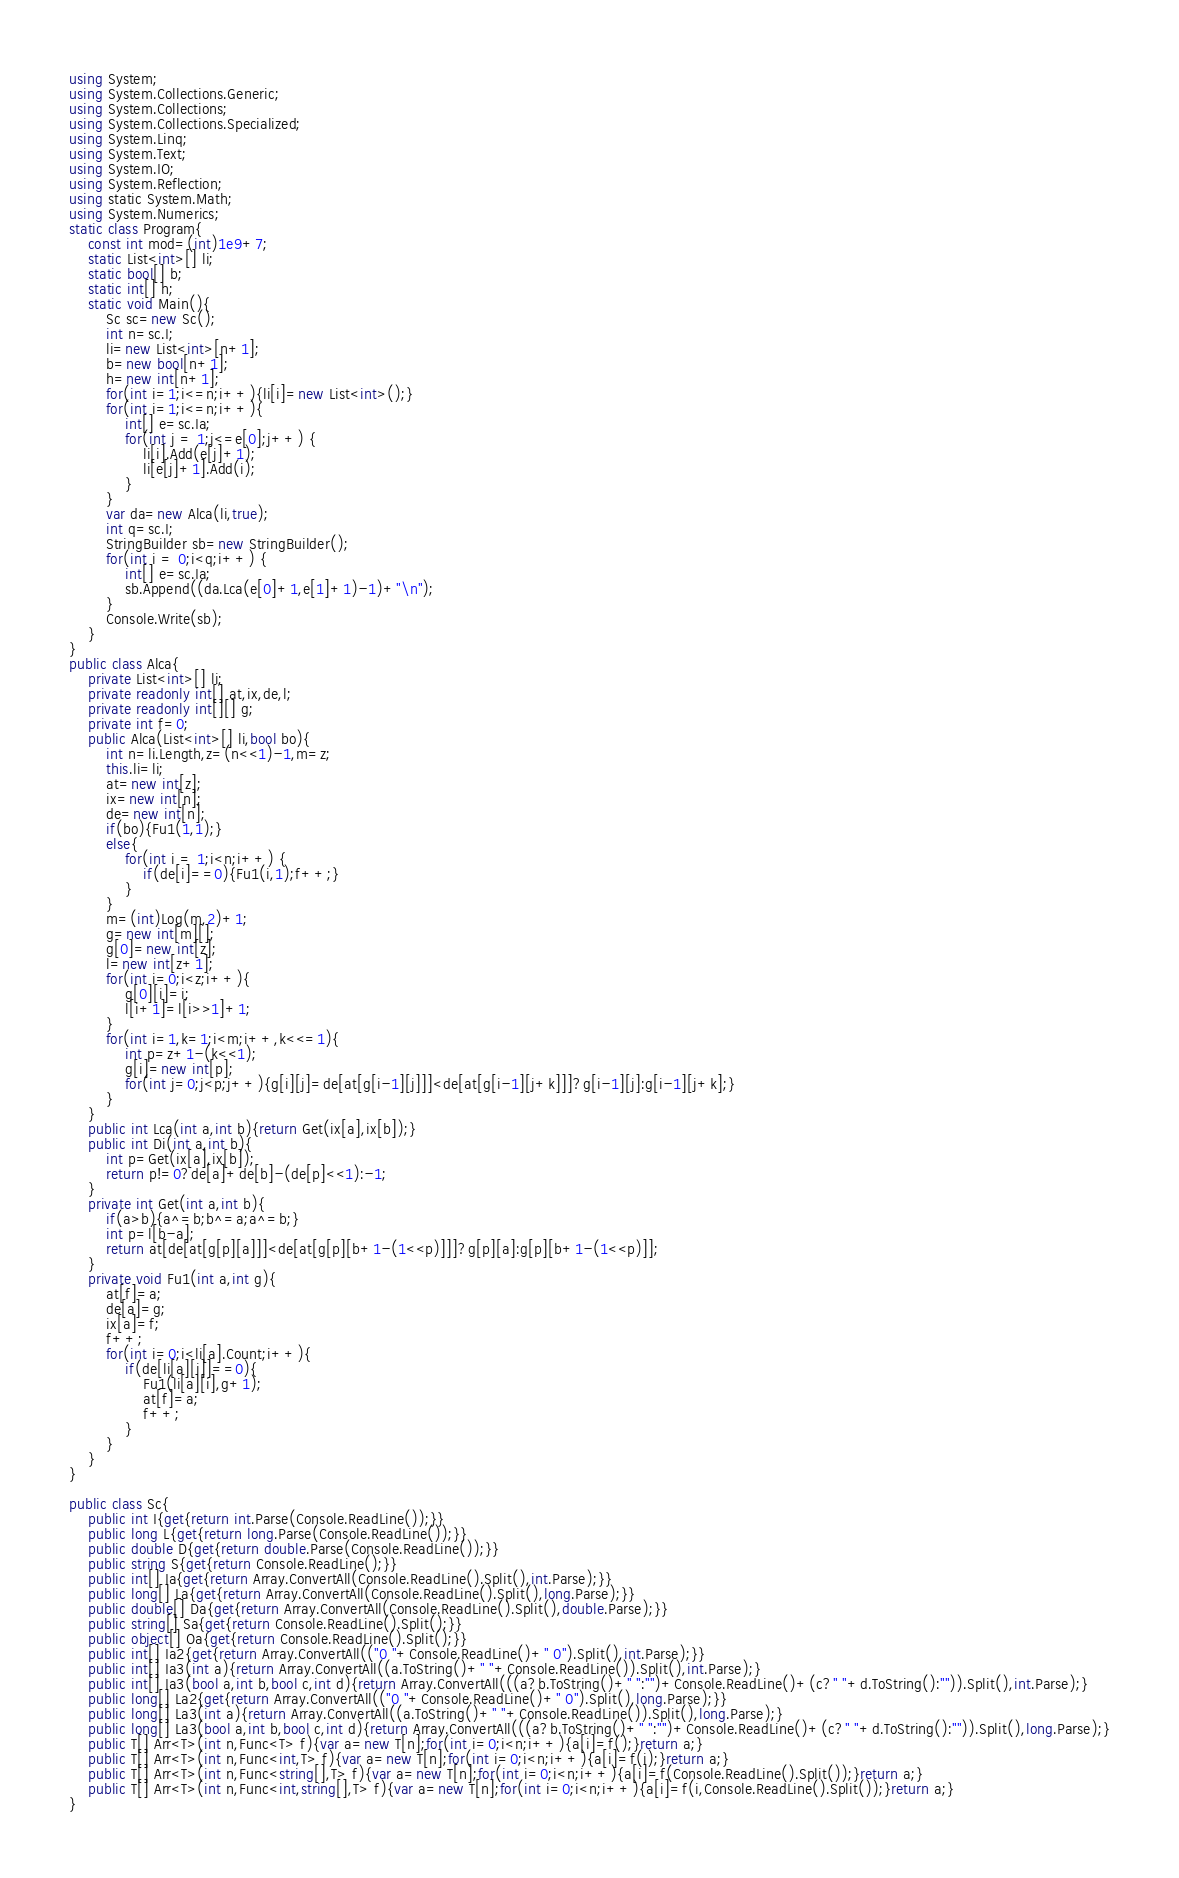<code> <loc_0><loc_0><loc_500><loc_500><_C#_>using System;
using System.Collections.Generic;
using System.Collections;
using System.Collections.Specialized;
using System.Linq;
using System.Text;
using System.IO;
using System.Reflection;
using static System.Math;
using System.Numerics;
static class Program{
	const int mod=(int)1e9+7;
	static List<int>[] li;
	static bool[] b;
	static int[] h;
	static void Main(){
		Sc sc=new Sc();
		int n=sc.I;
		li=new List<int>[n+1];
		b=new bool[n+1];
		h=new int[n+1];
		for(int i=1;i<=n;i++){li[i]=new List<int>();}
		for(int i=1;i<=n;i++){
			int[] e=sc.Ia;
			for(int j = 1;j<=e[0];j++) {
				li[i].Add(e[j]+1);
				li[e[j]+1].Add(i);
			}
		}
		var da=new Alca(li,true);
		int q=sc.I;
		StringBuilder sb=new StringBuilder();
		for(int i = 0;i<q;i++) {
			int[] e=sc.Ia;
			sb.Append((da.Lca(e[0]+1,e[1]+1)-1)+"\n");
		}
		Console.Write(sb);
	}
}
public class Alca{
	private List<int>[] li;
	private readonly int[] at,ix,de,l;
	private readonly int[][] g;
	private int f=0;
	public Alca(List<int>[] li,bool bo){
		int n=li.Length,z=(n<<1)-1,m=z;
		this.li=li;
		at=new int[z];
		ix=new int[n];
		de=new int[n];
		if(bo){Fu1(1,1);}
		else{
			for(int i = 1;i<n;i++) {
				if(de[i]==0){Fu1(i,1);f++;}
			}
		}
		m=(int)Log(m,2)+1;
		g=new int[m][];
		g[0]=new int[z];
		l=new int[z+1];
		for(int i=0;i<z;i++){
			g[0][i]=i;
			l[i+1]=l[i>>1]+1;
		}
		for(int i=1,k=1;i<m;i++,k<<=1){
			int p=z+1-(k<<1);
			g[i]=new int[p];
			for(int j=0;j<p;j++){g[i][j]=de[at[g[i-1][j]]]<de[at[g[i-1][j+k]]]?g[i-1][j]:g[i-1][j+k];}
		}
	}
	public int Lca(int a,int b){return Get(ix[a],ix[b]);}
	public int Di(int a,int b){
		int p=Get(ix[a],ix[b]);
		return p!=0?de[a]+de[b]-(de[p]<<1):-1;
	}
	private int Get(int a,int b){
		if(a>b){a^=b;b^=a;a^=b;}
		int p=l[b-a];
		return at[de[at[g[p][a]]]<de[at[g[p][b+1-(1<<p)]]]?g[p][a]:g[p][b+1-(1<<p)]];
	}
	private void Fu1(int a,int g){
		at[f]=a;
		de[a]=g;
		ix[a]=f;
		f++;
		for(int i=0;i<li[a].Count;i++){
			if(de[li[a][i]]==0){
				Fu1(li[a][i],g+1);
				at[f]=a;
				f++;
			}
		}
	}
}

public class Sc{
	public int I{get{return int.Parse(Console.ReadLine());}}
	public long L{get{return long.Parse(Console.ReadLine());}}
	public double D{get{return double.Parse(Console.ReadLine());}}
	public string S{get{return Console.ReadLine();}}
	public int[] Ia{get{return Array.ConvertAll(Console.ReadLine().Split(),int.Parse);}}
	public long[] La{get{return Array.ConvertAll(Console.ReadLine().Split(),long.Parse);}}
	public double[] Da{get{return Array.ConvertAll(Console.ReadLine().Split(),double.Parse);}}
	public string[] Sa{get{return Console.ReadLine().Split();}}
	public object[] Oa{get{return Console.ReadLine().Split();}}
	public int[] Ia2{get{return Array.ConvertAll(("0 "+Console.ReadLine()+" 0").Split(),int.Parse);}}
	public int[] Ia3(int a){return Array.ConvertAll((a.ToString()+" "+Console.ReadLine()).Split(),int.Parse);}
	public int[] Ia3(bool a,int b,bool c,int d){return Array.ConvertAll(((a?b.ToString()+" ":"")+Console.ReadLine()+(c?" "+d.ToString():"")).Split(),int.Parse);}
	public long[] La2{get{return Array.ConvertAll(("0 "+Console.ReadLine()+" 0").Split(),long.Parse);}}
	public long[] La3(int a){return Array.ConvertAll((a.ToString()+" "+Console.ReadLine()).Split(),long.Parse);}
	public long[] La3(bool a,int b,bool c,int d){return Array.ConvertAll(((a?b.ToString()+" ":"")+Console.ReadLine()+(c?" "+d.ToString():"")).Split(),long.Parse);}
	public T[] Arr<T>(int n,Func<T> f){var a=new T[n];for(int i=0;i<n;i++){a[i]=f();}return a;}
	public T[] Arr<T>(int n,Func<int,T> f){var a=new T[n];for(int i=0;i<n;i++){a[i]=f(i);}return a;}
	public T[] Arr<T>(int n,Func<string[],T> f){var a=new T[n];for(int i=0;i<n;i++){a[i]=f(Console.ReadLine().Split());}return a;}
	public T[] Arr<T>(int n,Func<int,string[],T> f){var a=new T[n];for(int i=0;i<n;i++){a[i]=f(i,Console.ReadLine().Split());}return a;}
}
</code> 